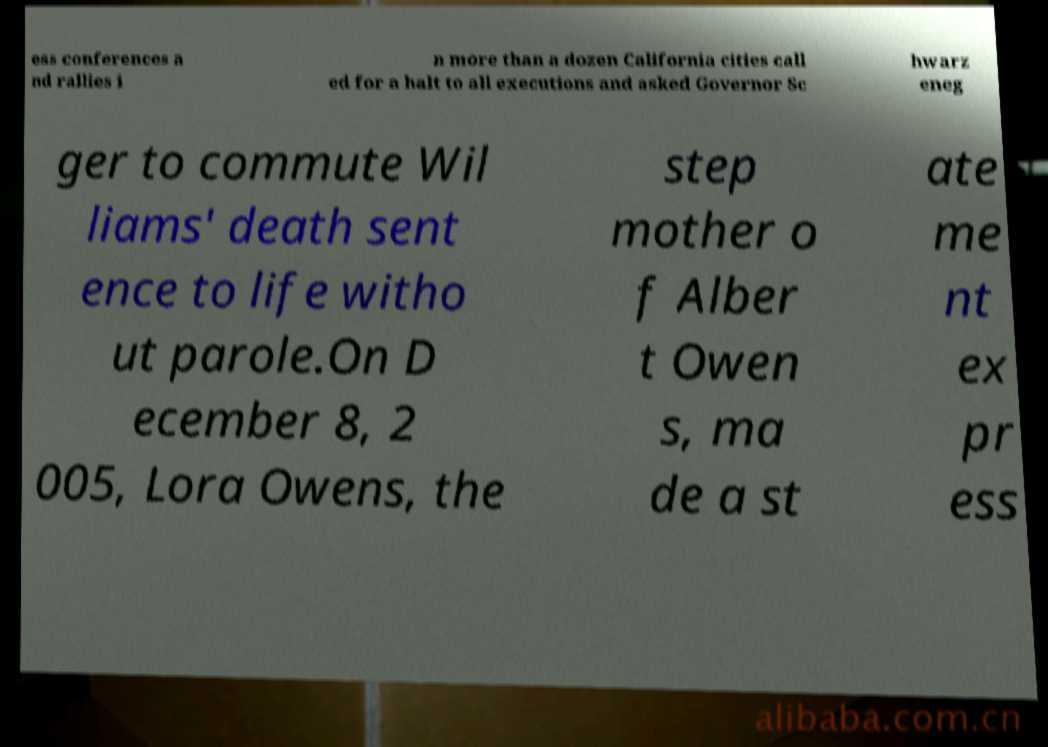Could you extract and type out the text from this image? ess conferences a nd rallies i n more than a dozen California cities call ed for a halt to all executions and asked Governor Sc hwarz eneg ger to commute Wil liams' death sent ence to life witho ut parole.On D ecember 8, 2 005, Lora Owens, the step mother o f Alber t Owen s, ma de a st ate me nt ex pr ess 